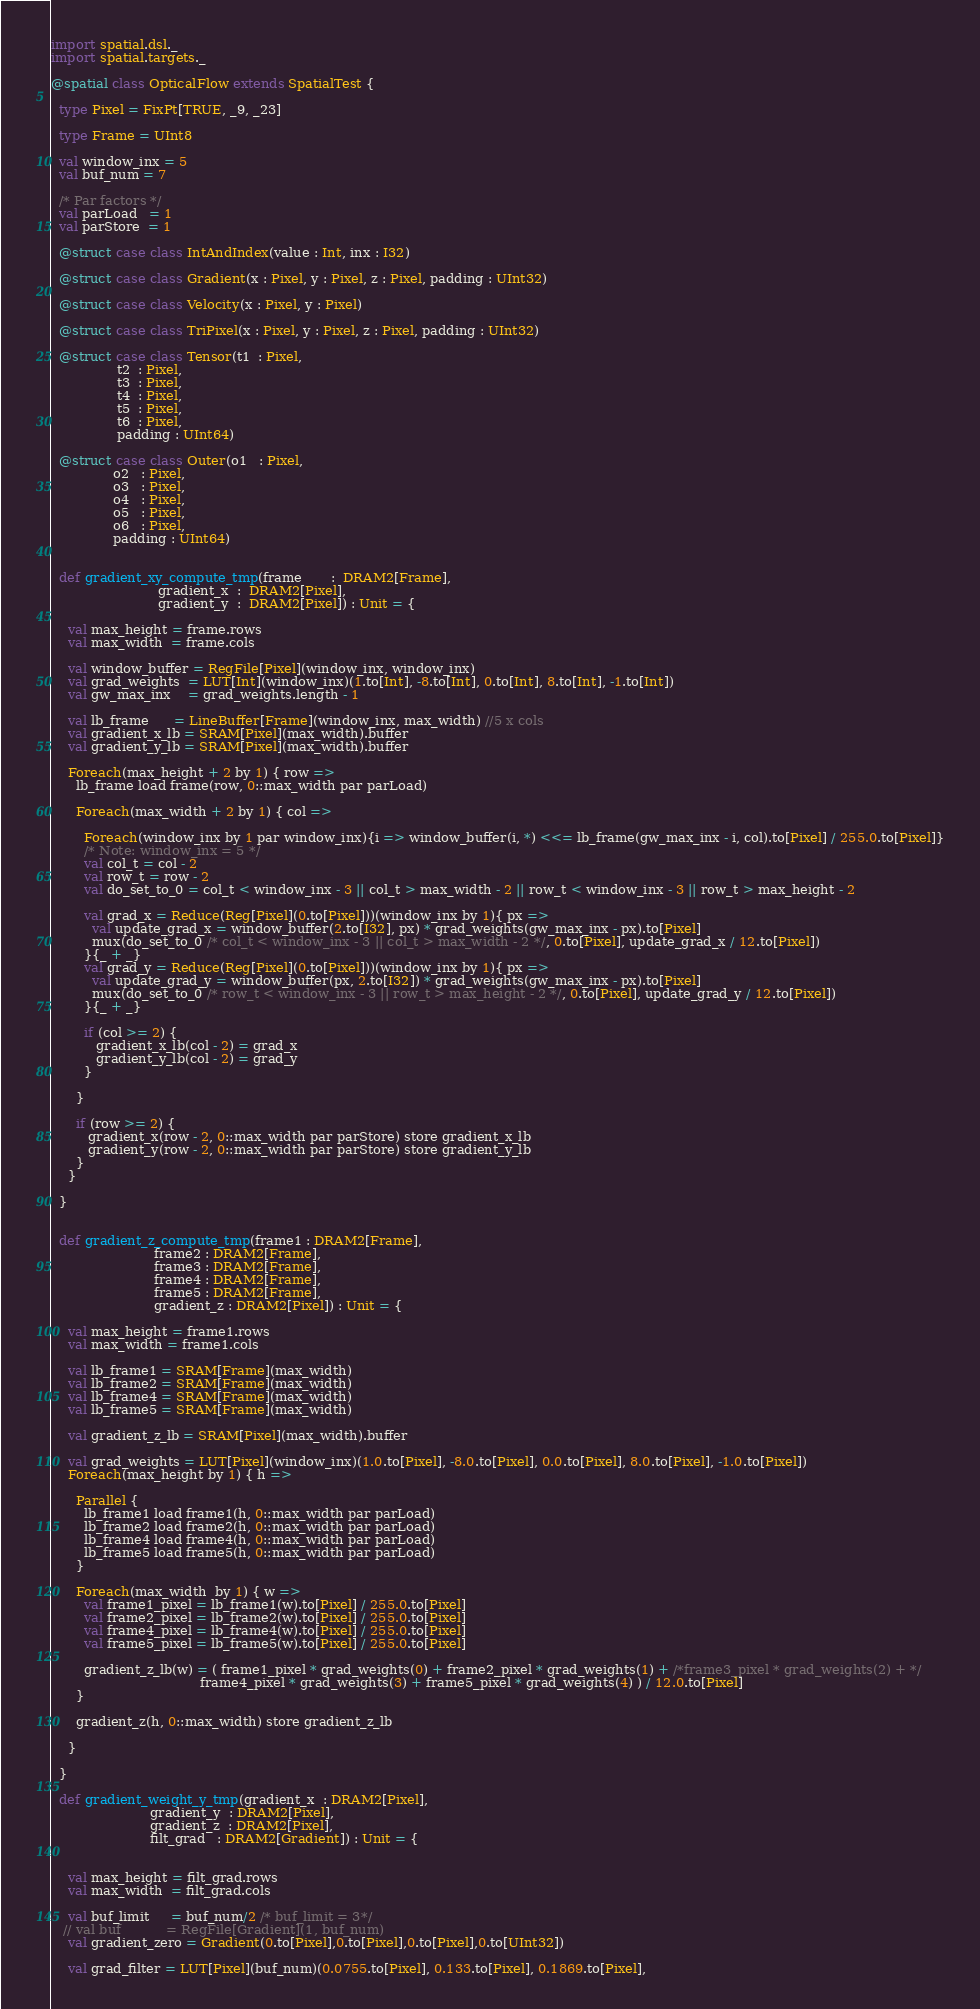<code> <loc_0><loc_0><loc_500><loc_500><_Scala_>import spatial.dsl._
import spatial.targets._

@spatial class OpticalFlow extends SpatialTest {

  type Pixel = FixPt[TRUE, _9, _23]

  type Frame = UInt8

  val window_inx = 5
  val buf_num = 7

  /* Par factors */
  val parLoad   = 1
  val parStore  = 1

  @struct case class IntAndIndex(value : Int, inx : I32)

  @struct case class Gradient(x : Pixel, y : Pixel, z : Pixel, padding : UInt32)

  @struct case class Velocity(x : Pixel, y : Pixel)

  @struct case class TriPixel(x : Pixel, y : Pixel, z : Pixel, padding : UInt32)

  @struct case class Tensor(t1  : Pixel, 
                t2  : Pixel,
                t3  : Pixel,
                t4  : Pixel,
                t5  : Pixel,
                t6  : Pixel, 
                padding : UInt64)

  @struct case class Outer(o1   : Pixel, 
               o2   : Pixel,
               o3   : Pixel,
               o4   : Pixel,
               o5   : Pixel,
               o6   : Pixel, 
               padding : UInt64)


  def gradient_xy_compute_tmp(frame       :  DRAM2[Frame], 
                          gradient_x  :  DRAM2[Pixel],
                          gradient_y  :  DRAM2[Pixel]) : Unit = {

    val max_height = frame.rows 
    val max_width  = frame.cols 

    val window_buffer = RegFile[Pixel](window_inx, window_inx)
    val grad_weights  = LUT[Int](window_inx)(1.to[Int], -8.to[Int], 0.to[Int], 8.to[Int], -1.to[Int])
    val gw_max_inx    = grad_weights.length - 1

    val lb_frame      = LineBuffer[Frame](window_inx, max_width) //5 x cols 
    val gradient_x_lb = SRAM[Pixel](max_width).buffer
    val gradient_y_lb = SRAM[Pixel](max_width).buffer

    Foreach(max_height + 2 by 1) { row =>
      lb_frame load frame(row, 0::max_width par parLoad)

      Foreach(max_width + 2 by 1) { col =>

        Foreach(window_inx by 1 par window_inx){i => window_buffer(i, *) <<= lb_frame(gw_max_inx - i, col).to[Pixel] / 255.0.to[Pixel]}
        /* Note: window_inx = 5 */
        val col_t = col - 2
        val row_t = row - 2
        val do_set_to_0 = col_t < window_inx - 3 || col_t > max_width - 2 || row_t < window_inx - 3 || row_t > max_height - 2 

        val grad_x = Reduce(Reg[Pixel](0.to[Pixel]))(window_inx by 1){ px =>
          val update_grad_x = window_buffer(2.to[I32], px) * grad_weights(gw_max_inx - px).to[Pixel]
          mux(do_set_to_0 /* col_t < window_inx - 3 || col_t > max_width - 2 */, 0.to[Pixel], update_grad_x / 12.to[Pixel])
        }{_ + _}
        val grad_y = Reduce(Reg[Pixel](0.to[Pixel]))(window_inx by 1){ px =>
          val update_grad_y = window_buffer(px, 2.to[I32]) * grad_weights(gw_max_inx - px).to[Pixel]
          mux(do_set_to_0 /* row_t < window_inx - 3 || row_t > max_height - 2 */, 0.to[Pixel], update_grad_y / 12.to[Pixel])
        }{_ + _}

        if (col >= 2) {
           gradient_x_lb(col - 2) = grad_x 
           gradient_y_lb(col - 2) = grad_y 
        }

      }

      if (row >= 2) {
         gradient_x(row - 2, 0::max_width par parStore) store gradient_x_lb
         gradient_y(row - 2, 0::max_width par parStore) store gradient_y_lb
      }
    }

  }


  def gradient_z_compute_tmp(frame1 : DRAM2[Frame],
                         frame2 : DRAM2[Frame],
                         frame3 : DRAM2[Frame],
                         frame4 : DRAM2[Frame],
                         frame5 : DRAM2[Frame],
                         gradient_z : DRAM2[Pixel]) : Unit = {

    val max_height = frame1.rows 
    val max_width = frame1.cols 

    val lb_frame1 = SRAM[Frame](max_width)
    val lb_frame2 = SRAM[Frame](max_width)
    val lb_frame4 = SRAM[Frame](max_width)
    val lb_frame5 = SRAM[Frame](max_width)

    val gradient_z_lb = SRAM[Pixel](max_width).buffer

    val grad_weights = LUT[Pixel](window_inx)(1.0.to[Pixel], -8.0.to[Pixel], 0.0.to[Pixel], 8.0.to[Pixel], -1.0.to[Pixel])
    Foreach(max_height by 1) { h =>

      Parallel {
        lb_frame1 load frame1(h, 0::max_width par parLoad)
        lb_frame2 load frame2(h, 0::max_width par parLoad)
        lb_frame4 load frame4(h, 0::max_width par parLoad)
        lb_frame5 load frame5(h, 0::max_width par parLoad)
      }

      Foreach(max_width  by 1) { w =>
        val frame1_pixel = lb_frame1(w).to[Pixel] / 255.0.to[Pixel]
        val frame2_pixel = lb_frame2(w).to[Pixel] / 255.0.to[Pixel]
        val frame4_pixel = lb_frame4(w).to[Pixel] / 255.0.to[Pixel]
        val frame5_pixel = lb_frame5(w).to[Pixel] / 255.0.to[Pixel]

        gradient_z_lb(w) = ( frame1_pixel * grad_weights(0) + frame2_pixel * grad_weights(1) + /*frame3_pixel * grad_weights(2) + */ 
                                    frame4_pixel * grad_weights(3) + frame5_pixel * grad_weights(4) ) / 12.0.to[Pixel] 
      }

      gradient_z(h, 0::max_width) store gradient_z_lb

    }
  
  }

  def gradient_weight_y_tmp(gradient_x  : DRAM2[Pixel], 
                        gradient_y  : DRAM2[Pixel], 
                        gradient_z  : DRAM2[Pixel], 
                        filt_grad   : DRAM2[Gradient]) : Unit = {

    
    val max_height = filt_grad.rows 
    val max_width  = filt_grad.cols

    val buf_limit     = buf_num/2 /* buf_limit = 3*/
   // val buf           = RegFile[Gradient](1, buf_num)
    val gradient_zero = Gradient(0.to[Pixel],0.to[Pixel],0.to[Pixel],0.to[UInt32])

    val grad_filter = LUT[Pixel](buf_num)(0.0755.to[Pixel], 0.133.to[Pixel], 0.1869.to[Pixel], </code> 